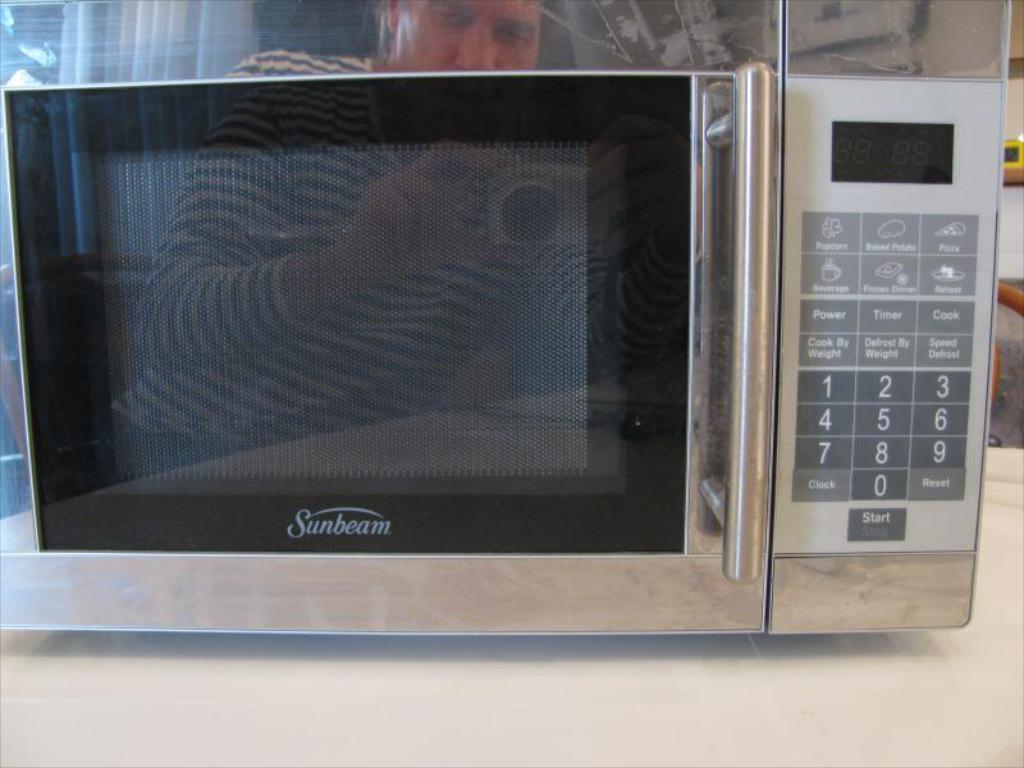Provide a one-sentence caption for the provided image. A man's reflection can be seen in the face of a Sunbeam microwave that is sitting on a counter. 